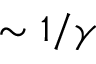Convert formula to latex. <formula><loc_0><loc_0><loc_500><loc_500>\sim 1 / \gamma</formula> 